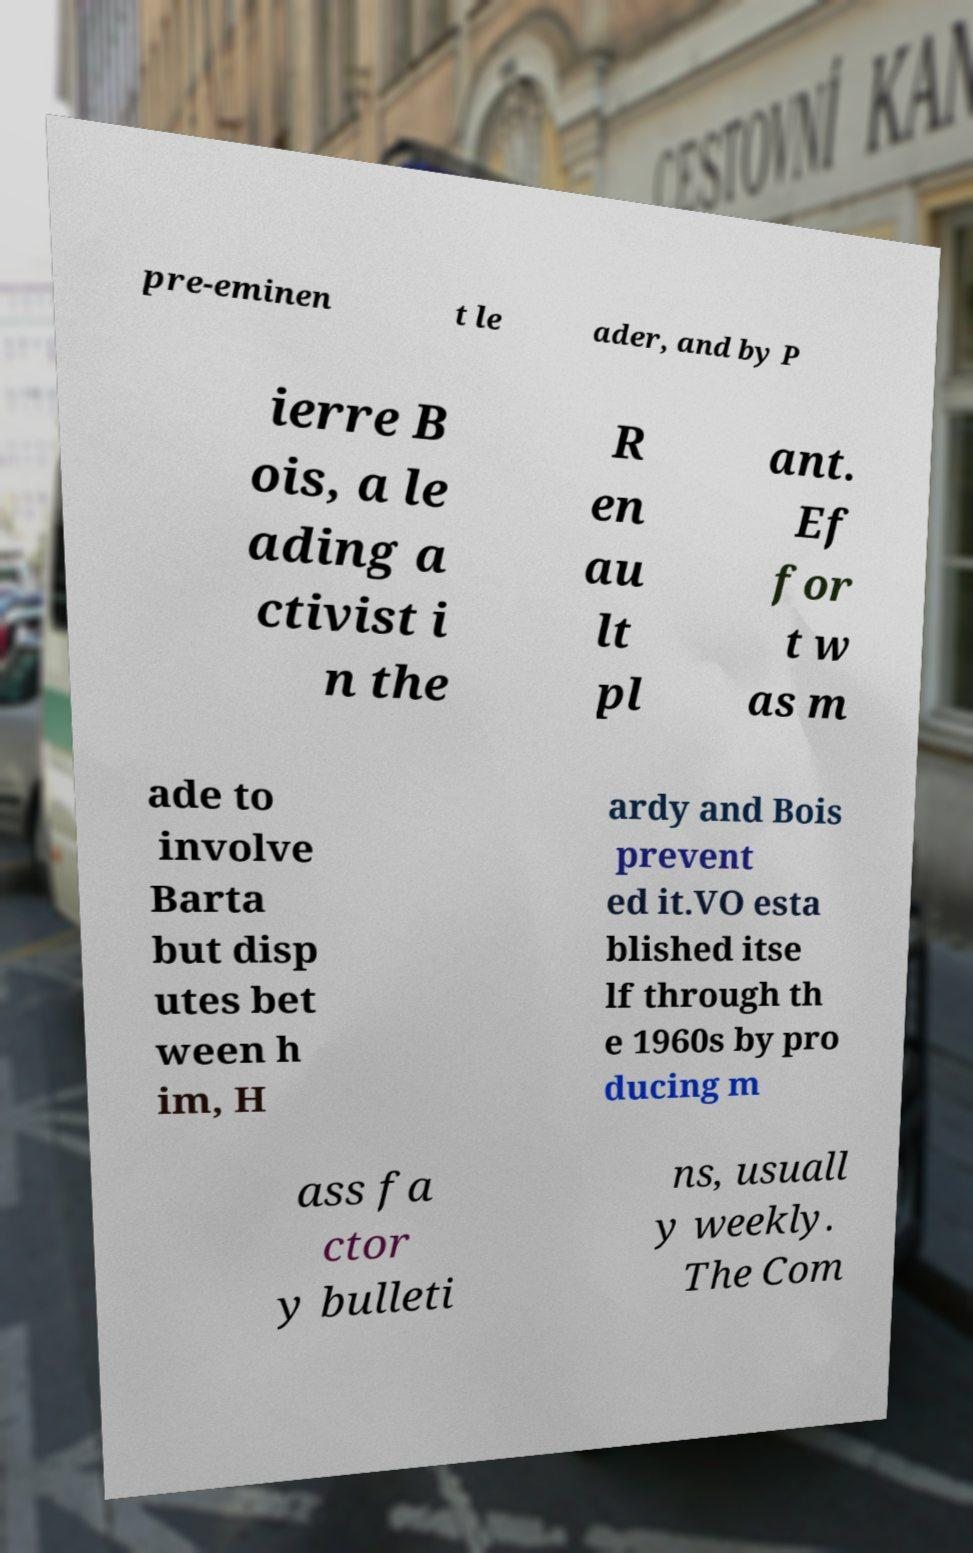I need the written content from this picture converted into text. Can you do that? pre-eminen t le ader, and by P ierre B ois, a le ading a ctivist i n the R en au lt pl ant. Ef for t w as m ade to involve Barta but disp utes bet ween h im, H ardy and Bois prevent ed it.VO esta blished itse lf through th e 1960s by pro ducing m ass fa ctor y bulleti ns, usuall y weekly. The Com 